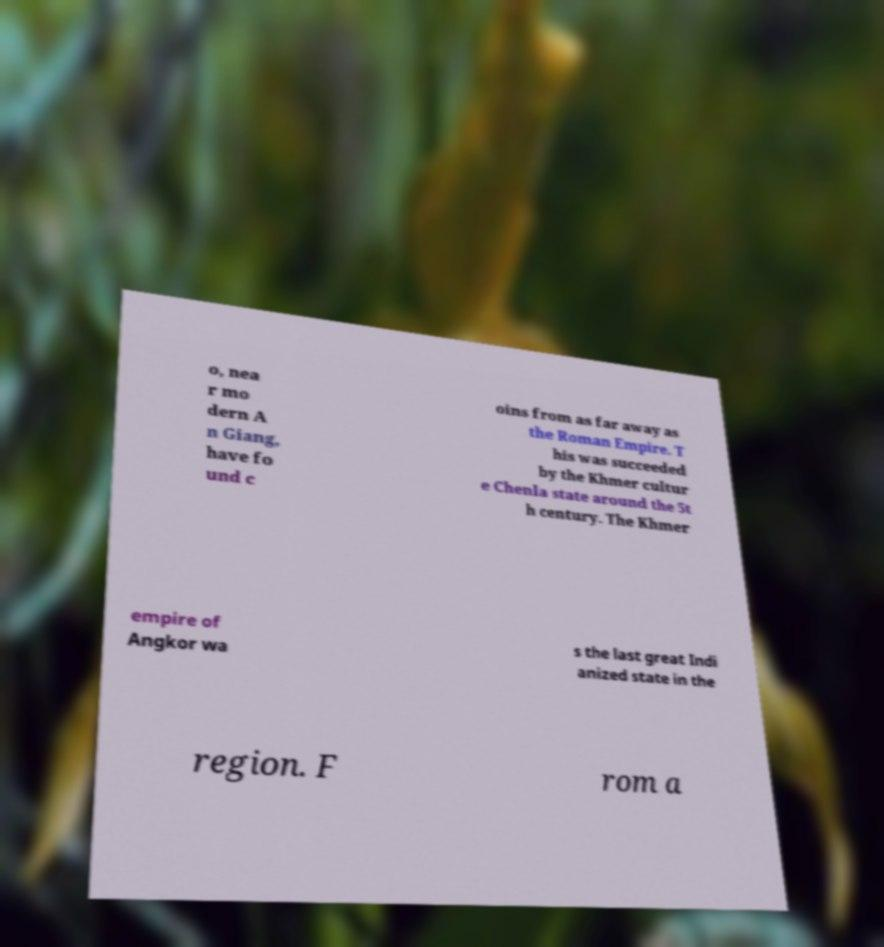For documentation purposes, I need the text within this image transcribed. Could you provide that? o, nea r mo dern A n Giang, have fo und c oins from as far away as the Roman Empire. T his was succeeded by the Khmer cultur e Chenla state around the 5t h century. The Khmer empire of Angkor wa s the last great Indi anized state in the region. F rom a 